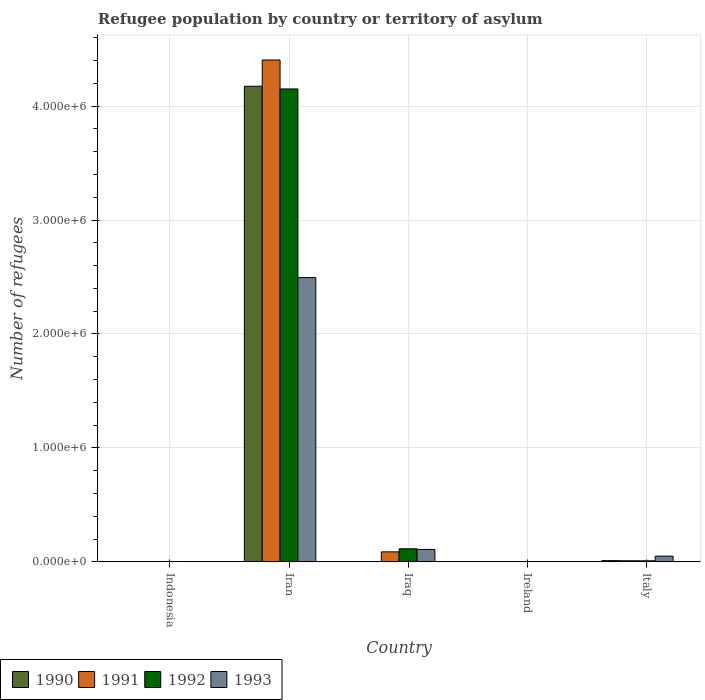How many groups of bars are there?
Your response must be concise. 5. How many bars are there on the 1st tick from the left?
Ensure brevity in your answer.  4. How many bars are there on the 5th tick from the right?
Your answer should be compact. 4. What is the label of the 5th group of bars from the left?
Give a very brief answer. Italy. What is the number of refugees in 1990 in Italy?
Your response must be concise. 1.08e+04. Across all countries, what is the maximum number of refugees in 1990?
Offer a terse response. 4.17e+06. Across all countries, what is the minimum number of refugees in 1990?
Make the answer very short. 360. In which country was the number of refugees in 1990 maximum?
Ensure brevity in your answer.  Iran. In which country was the number of refugees in 1993 minimum?
Give a very brief answer. Ireland. What is the total number of refugees in 1990 in the graph?
Make the answer very short. 4.19e+06. What is the difference between the number of refugees in 1990 in Indonesia and that in Italy?
Your answer should be compact. -7562. What is the difference between the number of refugees in 1993 in Ireland and the number of refugees in 1992 in Iran?
Give a very brief answer. -4.15e+06. What is the average number of refugees in 1993 per country?
Keep it short and to the point. 5.31e+05. What is the difference between the number of refugees of/in 1992 and number of refugees of/in 1991 in Ireland?
Make the answer very short. 200. What is the ratio of the number of refugees in 1991 in Iraq to that in Italy?
Offer a very short reply. 8.97. Is the difference between the number of refugees in 1992 in Ireland and Italy greater than the difference between the number of refugees in 1991 in Ireland and Italy?
Your answer should be compact. Yes. What is the difference between the highest and the second highest number of refugees in 1992?
Your response must be concise. 1.06e+05. What is the difference between the highest and the lowest number of refugees in 1993?
Make the answer very short. 2.49e+06. Is it the case that in every country, the sum of the number of refugees in 1992 and number of refugees in 1993 is greater than the sum of number of refugees in 1991 and number of refugees in 1990?
Ensure brevity in your answer.  No. What does the 2nd bar from the left in Ireland represents?
Your answer should be very brief. 1991. Is it the case that in every country, the sum of the number of refugees in 1991 and number of refugees in 1992 is greater than the number of refugees in 1990?
Your response must be concise. Yes. How many bars are there?
Give a very brief answer. 20. Are all the bars in the graph horizontal?
Provide a succinct answer. No. How many countries are there in the graph?
Give a very brief answer. 5. Are the values on the major ticks of Y-axis written in scientific E-notation?
Keep it short and to the point. Yes. Does the graph contain any zero values?
Your answer should be compact. No. How are the legend labels stacked?
Your answer should be compact. Horizontal. What is the title of the graph?
Offer a terse response. Refugee population by country or territory of asylum. Does "1987" appear as one of the legend labels in the graph?
Your response must be concise. No. What is the label or title of the X-axis?
Provide a short and direct response. Country. What is the label or title of the Y-axis?
Offer a very short reply. Number of refugees. What is the Number of refugees of 1990 in Indonesia?
Offer a very short reply. 3278. What is the Number of refugees in 1991 in Indonesia?
Offer a very short reply. 3156. What is the Number of refugees in 1992 in Indonesia?
Provide a short and direct response. 3530. What is the Number of refugees in 1993 in Indonesia?
Make the answer very short. 2402. What is the Number of refugees in 1990 in Iran?
Your answer should be very brief. 4.17e+06. What is the Number of refugees in 1991 in Iran?
Provide a short and direct response. 4.40e+06. What is the Number of refugees in 1992 in Iran?
Your answer should be very brief. 4.15e+06. What is the Number of refugees in 1993 in Iran?
Provide a short and direct response. 2.50e+06. What is the Number of refugees in 1990 in Iraq?
Offer a terse response. 900. What is the Number of refugees of 1991 in Iraq?
Offer a very short reply. 8.80e+04. What is the Number of refugees of 1992 in Iraq?
Your response must be concise. 1.15e+05. What is the Number of refugees of 1993 in Iraq?
Ensure brevity in your answer.  1.09e+05. What is the Number of refugees in 1990 in Ireland?
Your response must be concise. 360. What is the Number of refugees in 1991 in Ireland?
Your answer should be compact. 300. What is the Number of refugees in 1993 in Ireland?
Your response must be concise. 119. What is the Number of refugees in 1990 in Italy?
Offer a terse response. 1.08e+04. What is the Number of refugees of 1991 in Italy?
Keep it short and to the point. 9813. What is the Number of refugees of 1992 in Italy?
Offer a terse response. 9258. What is the Number of refugees of 1993 in Italy?
Make the answer very short. 5.03e+04. Across all countries, what is the maximum Number of refugees in 1990?
Make the answer very short. 4.17e+06. Across all countries, what is the maximum Number of refugees of 1991?
Provide a succinct answer. 4.40e+06. Across all countries, what is the maximum Number of refugees in 1992?
Give a very brief answer. 4.15e+06. Across all countries, what is the maximum Number of refugees of 1993?
Your answer should be compact. 2.50e+06. Across all countries, what is the minimum Number of refugees in 1990?
Ensure brevity in your answer.  360. Across all countries, what is the minimum Number of refugees of 1991?
Your answer should be compact. 300. Across all countries, what is the minimum Number of refugees of 1992?
Ensure brevity in your answer.  500. Across all countries, what is the minimum Number of refugees in 1993?
Give a very brief answer. 119. What is the total Number of refugees in 1990 in the graph?
Make the answer very short. 4.19e+06. What is the total Number of refugees of 1991 in the graph?
Ensure brevity in your answer.  4.51e+06. What is the total Number of refugees of 1992 in the graph?
Offer a very short reply. 4.28e+06. What is the total Number of refugees in 1993 in the graph?
Your answer should be very brief. 2.66e+06. What is the difference between the Number of refugees of 1990 in Indonesia and that in Iran?
Your answer should be compact. -4.17e+06. What is the difference between the Number of refugees of 1991 in Indonesia and that in Iran?
Keep it short and to the point. -4.40e+06. What is the difference between the Number of refugees of 1992 in Indonesia and that in Iran?
Ensure brevity in your answer.  -4.15e+06. What is the difference between the Number of refugees in 1993 in Indonesia and that in Iran?
Provide a short and direct response. -2.49e+06. What is the difference between the Number of refugees of 1990 in Indonesia and that in Iraq?
Offer a very short reply. 2378. What is the difference between the Number of refugees of 1991 in Indonesia and that in Iraq?
Ensure brevity in your answer.  -8.48e+04. What is the difference between the Number of refugees of 1992 in Indonesia and that in Iraq?
Keep it short and to the point. -1.11e+05. What is the difference between the Number of refugees in 1993 in Indonesia and that in Iraq?
Provide a short and direct response. -1.07e+05. What is the difference between the Number of refugees of 1990 in Indonesia and that in Ireland?
Provide a succinct answer. 2918. What is the difference between the Number of refugees in 1991 in Indonesia and that in Ireland?
Ensure brevity in your answer.  2856. What is the difference between the Number of refugees in 1992 in Indonesia and that in Ireland?
Make the answer very short. 3030. What is the difference between the Number of refugees of 1993 in Indonesia and that in Ireland?
Your answer should be very brief. 2283. What is the difference between the Number of refugees in 1990 in Indonesia and that in Italy?
Provide a short and direct response. -7562. What is the difference between the Number of refugees in 1991 in Indonesia and that in Italy?
Make the answer very short. -6657. What is the difference between the Number of refugees in 1992 in Indonesia and that in Italy?
Offer a very short reply. -5728. What is the difference between the Number of refugees in 1993 in Indonesia and that in Italy?
Provide a succinct answer. -4.79e+04. What is the difference between the Number of refugees in 1990 in Iran and that in Iraq?
Provide a short and direct response. 4.17e+06. What is the difference between the Number of refugees in 1991 in Iran and that in Iraq?
Give a very brief answer. 4.32e+06. What is the difference between the Number of refugees of 1992 in Iran and that in Iraq?
Your response must be concise. 4.04e+06. What is the difference between the Number of refugees in 1993 in Iran and that in Iraq?
Provide a succinct answer. 2.39e+06. What is the difference between the Number of refugees in 1990 in Iran and that in Ireland?
Give a very brief answer. 4.17e+06. What is the difference between the Number of refugees in 1991 in Iran and that in Ireland?
Ensure brevity in your answer.  4.40e+06. What is the difference between the Number of refugees of 1992 in Iran and that in Ireland?
Provide a short and direct response. 4.15e+06. What is the difference between the Number of refugees in 1993 in Iran and that in Ireland?
Offer a terse response. 2.49e+06. What is the difference between the Number of refugees in 1990 in Iran and that in Italy?
Your answer should be very brief. 4.16e+06. What is the difference between the Number of refugees in 1991 in Iran and that in Italy?
Keep it short and to the point. 4.40e+06. What is the difference between the Number of refugees of 1992 in Iran and that in Italy?
Provide a succinct answer. 4.14e+06. What is the difference between the Number of refugees of 1993 in Iran and that in Italy?
Your response must be concise. 2.44e+06. What is the difference between the Number of refugees of 1990 in Iraq and that in Ireland?
Ensure brevity in your answer.  540. What is the difference between the Number of refugees in 1991 in Iraq and that in Ireland?
Ensure brevity in your answer.  8.77e+04. What is the difference between the Number of refugees of 1992 in Iraq and that in Ireland?
Offer a very short reply. 1.14e+05. What is the difference between the Number of refugees of 1993 in Iraq and that in Ireland?
Ensure brevity in your answer.  1.09e+05. What is the difference between the Number of refugees of 1990 in Iraq and that in Italy?
Keep it short and to the point. -9940. What is the difference between the Number of refugees in 1991 in Iraq and that in Italy?
Provide a short and direct response. 7.82e+04. What is the difference between the Number of refugees in 1992 in Iraq and that in Italy?
Give a very brief answer. 1.06e+05. What is the difference between the Number of refugees of 1993 in Iraq and that in Italy?
Your answer should be very brief. 5.88e+04. What is the difference between the Number of refugees of 1990 in Ireland and that in Italy?
Your answer should be compact. -1.05e+04. What is the difference between the Number of refugees in 1991 in Ireland and that in Italy?
Provide a succinct answer. -9513. What is the difference between the Number of refugees of 1992 in Ireland and that in Italy?
Offer a very short reply. -8758. What is the difference between the Number of refugees of 1993 in Ireland and that in Italy?
Your response must be concise. -5.02e+04. What is the difference between the Number of refugees of 1990 in Indonesia and the Number of refugees of 1991 in Iran?
Provide a short and direct response. -4.40e+06. What is the difference between the Number of refugees of 1990 in Indonesia and the Number of refugees of 1992 in Iran?
Offer a very short reply. -4.15e+06. What is the difference between the Number of refugees in 1990 in Indonesia and the Number of refugees in 1993 in Iran?
Provide a succinct answer. -2.49e+06. What is the difference between the Number of refugees of 1991 in Indonesia and the Number of refugees of 1992 in Iran?
Ensure brevity in your answer.  -4.15e+06. What is the difference between the Number of refugees of 1991 in Indonesia and the Number of refugees of 1993 in Iran?
Your answer should be compact. -2.49e+06. What is the difference between the Number of refugees of 1992 in Indonesia and the Number of refugees of 1993 in Iran?
Provide a short and direct response. -2.49e+06. What is the difference between the Number of refugees of 1990 in Indonesia and the Number of refugees of 1991 in Iraq?
Your answer should be very brief. -8.47e+04. What is the difference between the Number of refugees of 1990 in Indonesia and the Number of refugees of 1992 in Iraq?
Keep it short and to the point. -1.12e+05. What is the difference between the Number of refugees of 1990 in Indonesia and the Number of refugees of 1993 in Iraq?
Provide a succinct answer. -1.06e+05. What is the difference between the Number of refugees of 1991 in Indonesia and the Number of refugees of 1992 in Iraq?
Your answer should be very brief. -1.12e+05. What is the difference between the Number of refugees in 1991 in Indonesia and the Number of refugees in 1993 in Iraq?
Your answer should be compact. -1.06e+05. What is the difference between the Number of refugees in 1992 in Indonesia and the Number of refugees in 1993 in Iraq?
Your answer should be compact. -1.06e+05. What is the difference between the Number of refugees in 1990 in Indonesia and the Number of refugees in 1991 in Ireland?
Provide a short and direct response. 2978. What is the difference between the Number of refugees in 1990 in Indonesia and the Number of refugees in 1992 in Ireland?
Provide a succinct answer. 2778. What is the difference between the Number of refugees of 1990 in Indonesia and the Number of refugees of 1993 in Ireland?
Ensure brevity in your answer.  3159. What is the difference between the Number of refugees in 1991 in Indonesia and the Number of refugees in 1992 in Ireland?
Keep it short and to the point. 2656. What is the difference between the Number of refugees in 1991 in Indonesia and the Number of refugees in 1993 in Ireland?
Offer a terse response. 3037. What is the difference between the Number of refugees of 1992 in Indonesia and the Number of refugees of 1993 in Ireland?
Provide a succinct answer. 3411. What is the difference between the Number of refugees in 1990 in Indonesia and the Number of refugees in 1991 in Italy?
Your answer should be compact. -6535. What is the difference between the Number of refugees in 1990 in Indonesia and the Number of refugees in 1992 in Italy?
Make the answer very short. -5980. What is the difference between the Number of refugees of 1990 in Indonesia and the Number of refugees of 1993 in Italy?
Keep it short and to the point. -4.70e+04. What is the difference between the Number of refugees in 1991 in Indonesia and the Number of refugees in 1992 in Italy?
Provide a succinct answer. -6102. What is the difference between the Number of refugees in 1991 in Indonesia and the Number of refugees in 1993 in Italy?
Provide a short and direct response. -4.71e+04. What is the difference between the Number of refugees in 1992 in Indonesia and the Number of refugees in 1993 in Italy?
Your response must be concise. -4.67e+04. What is the difference between the Number of refugees in 1990 in Iran and the Number of refugees in 1991 in Iraq?
Provide a short and direct response. 4.09e+06. What is the difference between the Number of refugees in 1990 in Iran and the Number of refugees in 1992 in Iraq?
Your answer should be compact. 4.06e+06. What is the difference between the Number of refugees in 1990 in Iran and the Number of refugees in 1993 in Iraq?
Provide a short and direct response. 4.07e+06. What is the difference between the Number of refugees of 1991 in Iran and the Number of refugees of 1992 in Iraq?
Provide a succinct answer. 4.29e+06. What is the difference between the Number of refugees in 1991 in Iran and the Number of refugees in 1993 in Iraq?
Your response must be concise. 4.30e+06. What is the difference between the Number of refugees in 1992 in Iran and the Number of refugees in 1993 in Iraq?
Offer a terse response. 4.04e+06. What is the difference between the Number of refugees of 1990 in Iran and the Number of refugees of 1991 in Ireland?
Your response must be concise. 4.17e+06. What is the difference between the Number of refugees of 1990 in Iran and the Number of refugees of 1992 in Ireland?
Your response must be concise. 4.17e+06. What is the difference between the Number of refugees of 1990 in Iran and the Number of refugees of 1993 in Ireland?
Ensure brevity in your answer.  4.17e+06. What is the difference between the Number of refugees of 1991 in Iran and the Number of refugees of 1992 in Ireland?
Make the answer very short. 4.40e+06. What is the difference between the Number of refugees in 1991 in Iran and the Number of refugees in 1993 in Ireland?
Provide a short and direct response. 4.40e+06. What is the difference between the Number of refugees in 1992 in Iran and the Number of refugees in 1993 in Ireland?
Make the answer very short. 4.15e+06. What is the difference between the Number of refugees of 1990 in Iran and the Number of refugees of 1991 in Italy?
Offer a terse response. 4.16e+06. What is the difference between the Number of refugees in 1990 in Iran and the Number of refugees in 1992 in Italy?
Provide a succinct answer. 4.17e+06. What is the difference between the Number of refugees in 1990 in Iran and the Number of refugees in 1993 in Italy?
Your answer should be very brief. 4.12e+06. What is the difference between the Number of refugees of 1991 in Iran and the Number of refugees of 1992 in Italy?
Ensure brevity in your answer.  4.40e+06. What is the difference between the Number of refugees of 1991 in Iran and the Number of refugees of 1993 in Italy?
Provide a succinct answer. 4.35e+06. What is the difference between the Number of refugees of 1992 in Iran and the Number of refugees of 1993 in Italy?
Make the answer very short. 4.10e+06. What is the difference between the Number of refugees of 1990 in Iraq and the Number of refugees of 1991 in Ireland?
Provide a succinct answer. 600. What is the difference between the Number of refugees of 1990 in Iraq and the Number of refugees of 1992 in Ireland?
Make the answer very short. 400. What is the difference between the Number of refugees of 1990 in Iraq and the Number of refugees of 1993 in Ireland?
Keep it short and to the point. 781. What is the difference between the Number of refugees of 1991 in Iraq and the Number of refugees of 1992 in Ireland?
Your answer should be very brief. 8.75e+04. What is the difference between the Number of refugees in 1991 in Iraq and the Number of refugees in 1993 in Ireland?
Your response must be concise. 8.79e+04. What is the difference between the Number of refugees of 1992 in Iraq and the Number of refugees of 1993 in Ireland?
Make the answer very short. 1.15e+05. What is the difference between the Number of refugees in 1990 in Iraq and the Number of refugees in 1991 in Italy?
Your answer should be very brief. -8913. What is the difference between the Number of refugees in 1990 in Iraq and the Number of refugees in 1992 in Italy?
Offer a very short reply. -8358. What is the difference between the Number of refugees of 1990 in Iraq and the Number of refugees of 1993 in Italy?
Make the answer very short. -4.94e+04. What is the difference between the Number of refugees of 1991 in Iraq and the Number of refugees of 1992 in Italy?
Your response must be concise. 7.87e+04. What is the difference between the Number of refugees of 1991 in Iraq and the Number of refugees of 1993 in Italy?
Give a very brief answer. 3.77e+04. What is the difference between the Number of refugees in 1992 in Iraq and the Number of refugees in 1993 in Italy?
Ensure brevity in your answer.  6.47e+04. What is the difference between the Number of refugees in 1990 in Ireland and the Number of refugees in 1991 in Italy?
Provide a short and direct response. -9453. What is the difference between the Number of refugees of 1990 in Ireland and the Number of refugees of 1992 in Italy?
Your response must be concise. -8898. What is the difference between the Number of refugees in 1990 in Ireland and the Number of refugees in 1993 in Italy?
Keep it short and to the point. -4.99e+04. What is the difference between the Number of refugees of 1991 in Ireland and the Number of refugees of 1992 in Italy?
Make the answer very short. -8958. What is the difference between the Number of refugees in 1991 in Ireland and the Number of refugees in 1993 in Italy?
Ensure brevity in your answer.  -5.00e+04. What is the difference between the Number of refugees of 1992 in Ireland and the Number of refugees of 1993 in Italy?
Offer a terse response. -4.98e+04. What is the average Number of refugees of 1990 per country?
Provide a short and direct response. 8.38e+05. What is the average Number of refugees of 1991 per country?
Offer a very short reply. 9.01e+05. What is the average Number of refugees in 1992 per country?
Ensure brevity in your answer.  8.56e+05. What is the average Number of refugees in 1993 per country?
Make the answer very short. 5.31e+05. What is the difference between the Number of refugees of 1990 and Number of refugees of 1991 in Indonesia?
Offer a very short reply. 122. What is the difference between the Number of refugees of 1990 and Number of refugees of 1992 in Indonesia?
Your answer should be compact. -252. What is the difference between the Number of refugees in 1990 and Number of refugees in 1993 in Indonesia?
Keep it short and to the point. 876. What is the difference between the Number of refugees in 1991 and Number of refugees in 1992 in Indonesia?
Provide a short and direct response. -374. What is the difference between the Number of refugees in 1991 and Number of refugees in 1993 in Indonesia?
Your response must be concise. 754. What is the difference between the Number of refugees of 1992 and Number of refugees of 1993 in Indonesia?
Ensure brevity in your answer.  1128. What is the difference between the Number of refugees in 1990 and Number of refugees in 1991 in Iran?
Your response must be concise. -2.31e+05. What is the difference between the Number of refugees in 1990 and Number of refugees in 1992 in Iran?
Give a very brief answer. 2.37e+04. What is the difference between the Number of refugees in 1990 and Number of refugees in 1993 in Iran?
Give a very brief answer. 1.68e+06. What is the difference between the Number of refugees of 1991 and Number of refugees of 1992 in Iran?
Offer a terse response. 2.54e+05. What is the difference between the Number of refugees of 1991 and Number of refugees of 1993 in Iran?
Offer a very short reply. 1.91e+06. What is the difference between the Number of refugees in 1992 and Number of refugees in 1993 in Iran?
Make the answer very short. 1.66e+06. What is the difference between the Number of refugees in 1990 and Number of refugees in 1991 in Iraq?
Your response must be concise. -8.71e+04. What is the difference between the Number of refugees in 1990 and Number of refugees in 1992 in Iraq?
Offer a very short reply. -1.14e+05. What is the difference between the Number of refugees of 1990 and Number of refugees of 1993 in Iraq?
Give a very brief answer. -1.08e+05. What is the difference between the Number of refugees in 1991 and Number of refugees in 1992 in Iraq?
Your answer should be compact. -2.70e+04. What is the difference between the Number of refugees in 1991 and Number of refugees in 1993 in Iraq?
Keep it short and to the point. -2.11e+04. What is the difference between the Number of refugees of 1992 and Number of refugees of 1993 in Iraq?
Offer a very short reply. 5934. What is the difference between the Number of refugees of 1990 and Number of refugees of 1991 in Ireland?
Provide a succinct answer. 60. What is the difference between the Number of refugees in 1990 and Number of refugees in 1992 in Ireland?
Give a very brief answer. -140. What is the difference between the Number of refugees in 1990 and Number of refugees in 1993 in Ireland?
Give a very brief answer. 241. What is the difference between the Number of refugees of 1991 and Number of refugees of 1992 in Ireland?
Your answer should be very brief. -200. What is the difference between the Number of refugees of 1991 and Number of refugees of 1993 in Ireland?
Your answer should be compact. 181. What is the difference between the Number of refugees in 1992 and Number of refugees in 1993 in Ireland?
Keep it short and to the point. 381. What is the difference between the Number of refugees of 1990 and Number of refugees of 1991 in Italy?
Your answer should be compact. 1027. What is the difference between the Number of refugees in 1990 and Number of refugees in 1992 in Italy?
Ensure brevity in your answer.  1582. What is the difference between the Number of refugees of 1990 and Number of refugees of 1993 in Italy?
Offer a very short reply. -3.94e+04. What is the difference between the Number of refugees of 1991 and Number of refugees of 1992 in Italy?
Provide a short and direct response. 555. What is the difference between the Number of refugees in 1991 and Number of refugees in 1993 in Italy?
Keep it short and to the point. -4.05e+04. What is the difference between the Number of refugees in 1992 and Number of refugees in 1993 in Italy?
Keep it short and to the point. -4.10e+04. What is the ratio of the Number of refugees of 1990 in Indonesia to that in Iran?
Your answer should be very brief. 0. What is the ratio of the Number of refugees of 1991 in Indonesia to that in Iran?
Provide a short and direct response. 0. What is the ratio of the Number of refugees of 1992 in Indonesia to that in Iran?
Keep it short and to the point. 0. What is the ratio of the Number of refugees of 1993 in Indonesia to that in Iran?
Your response must be concise. 0. What is the ratio of the Number of refugees of 1990 in Indonesia to that in Iraq?
Give a very brief answer. 3.64. What is the ratio of the Number of refugees in 1991 in Indonesia to that in Iraq?
Ensure brevity in your answer.  0.04. What is the ratio of the Number of refugees of 1992 in Indonesia to that in Iraq?
Ensure brevity in your answer.  0.03. What is the ratio of the Number of refugees of 1993 in Indonesia to that in Iraq?
Offer a terse response. 0.02. What is the ratio of the Number of refugees in 1990 in Indonesia to that in Ireland?
Make the answer very short. 9.11. What is the ratio of the Number of refugees of 1991 in Indonesia to that in Ireland?
Ensure brevity in your answer.  10.52. What is the ratio of the Number of refugees of 1992 in Indonesia to that in Ireland?
Keep it short and to the point. 7.06. What is the ratio of the Number of refugees of 1993 in Indonesia to that in Ireland?
Offer a terse response. 20.18. What is the ratio of the Number of refugees of 1990 in Indonesia to that in Italy?
Offer a very short reply. 0.3. What is the ratio of the Number of refugees in 1991 in Indonesia to that in Italy?
Keep it short and to the point. 0.32. What is the ratio of the Number of refugees of 1992 in Indonesia to that in Italy?
Provide a succinct answer. 0.38. What is the ratio of the Number of refugees in 1993 in Indonesia to that in Italy?
Provide a succinct answer. 0.05. What is the ratio of the Number of refugees of 1990 in Iran to that in Iraq?
Your answer should be very brief. 4638.22. What is the ratio of the Number of refugees of 1991 in Iran to that in Iraq?
Make the answer very short. 50.06. What is the ratio of the Number of refugees of 1992 in Iran to that in Iraq?
Provide a succinct answer. 36.09. What is the ratio of the Number of refugees in 1993 in Iran to that in Iraq?
Offer a very short reply. 22.88. What is the ratio of the Number of refugees of 1990 in Iran to that in Ireland?
Offer a terse response. 1.16e+04. What is the ratio of the Number of refugees of 1991 in Iran to that in Ireland?
Your answer should be very brief. 1.47e+04. What is the ratio of the Number of refugees of 1992 in Iran to that in Ireland?
Give a very brief answer. 8301.45. What is the ratio of the Number of refugees in 1993 in Iran to that in Ireland?
Give a very brief answer. 2.10e+04. What is the ratio of the Number of refugees in 1990 in Iran to that in Italy?
Your response must be concise. 385.09. What is the ratio of the Number of refugees in 1991 in Iran to that in Italy?
Provide a short and direct response. 448.89. What is the ratio of the Number of refugees in 1992 in Iran to that in Italy?
Offer a terse response. 448.34. What is the ratio of the Number of refugees of 1993 in Iran to that in Italy?
Your answer should be very brief. 49.63. What is the ratio of the Number of refugees of 1990 in Iraq to that in Ireland?
Give a very brief answer. 2.5. What is the ratio of the Number of refugees of 1991 in Iraq to that in Ireland?
Provide a succinct answer. 293.3. What is the ratio of the Number of refugees in 1992 in Iraq to that in Ireland?
Offer a very short reply. 230. What is the ratio of the Number of refugees of 1993 in Iraq to that in Ireland?
Offer a terse response. 916.52. What is the ratio of the Number of refugees of 1990 in Iraq to that in Italy?
Make the answer very short. 0.08. What is the ratio of the Number of refugees in 1991 in Iraq to that in Italy?
Give a very brief answer. 8.97. What is the ratio of the Number of refugees in 1992 in Iraq to that in Italy?
Make the answer very short. 12.42. What is the ratio of the Number of refugees in 1993 in Iraq to that in Italy?
Make the answer very short. 2.17. What is the ratio of the Number of refugees of 1990 in Ireland to that in Italy?
Offer a very short reply. 0.03. What is the ratio of the Number of refugees in 1991 in Ireland to that in Italy?
Your answer should be compact. 0.03. What is the ratio of the Number of refugees of 1992 in Ireland to that in Italy?
Ensure brevity in your answer.  0.05. What is the ratio of the Number of refugees of 1993 in Ireland to that in Italy?
Your answer should be compact. 0. What is the difference between the highest and the second highest Number of refugees in 1990?
Offer a very short reply. 4.16e+06. What is the difference between the highest and the second highest Number of refugees in 1991?
Give a very brief answer. 4.32e+06. What is the difference between the highest and the second highest Number of refugees of 1992?
Keep it short and to the point. 4.04e+06. What is the difference between the highest and the second highest Number of refugees in 1993?
Keep it short and to the point. 2.39e+06. What is the difference between the highest and the lowest Number of refugees of 1990?
Provide a succinct answer. 4.17e+06. What is the difference between the highest and the lowest Number of refugees of 1991?
Provide a short and direct response. 4.40e+06. What is the difference between the highest and the lowest Number of refugees in 1992?
Provide a short and direct response. 4.15e+06. What is the difference between the highest and the lowest Number of refugees of 1993?
Ensure brevity in your answer.  2.49e+06. 